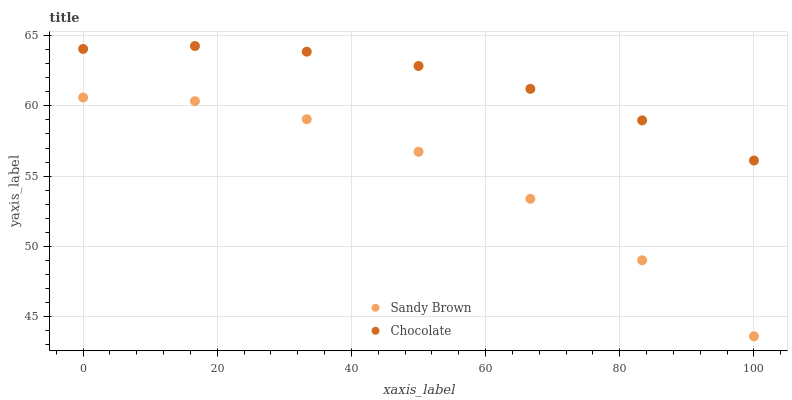Does Sandy Brown have the minimum area under the curve?
Answer yes or no. Yes. Does Chocolate have the maximum area under the curve?
Answer yes or no. Yes. Does Chocolate have the minimum area under the curve?
Answer yes or no. No. Is Chocolate the smoothest?
Answer yes or no. Yes. Is Sandy Brown the roughest?
Answer yes or no. Yes. Is Chocolate the roughest?
Answer yes or no. No. Does Sandy Brown have the lowest value?
Answer yes or no. Yes. Does Chocolate have the lowest value?
Answer yes or no. No. Does Chocolate have the highest value?
Answer yes or no. Yes. Is Sandy Brown less than Chocolate?
Answer yes or no. Yes. Is Chocolate greater than Sandy Brown?
Answer yes or no. Yes. Does Sandy Brown intersect Chocolate?
Answer yes or no. No. 